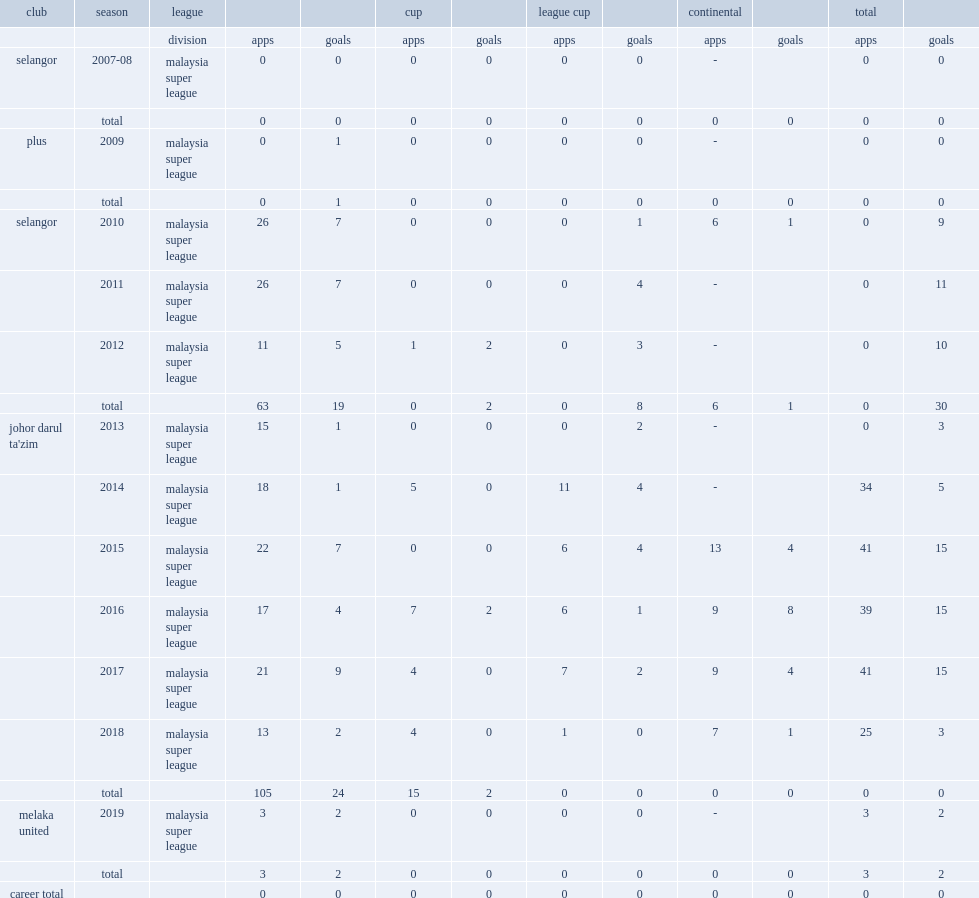In 2015, which league did safiq rahim appear for johor darul ta'zim? Malaysia super league. 